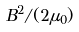Convert formula to latex. <formula><loc_0><loc_0><loc_500><loc_500>B ^ { 2 } / ( 2 \mu _ { 0 } )</formula> 